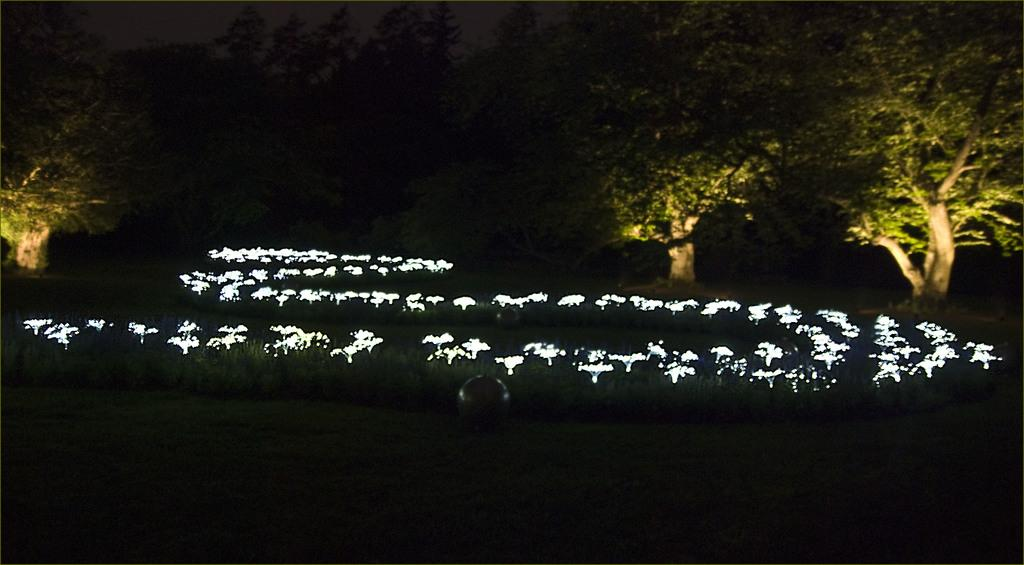What type of natural elements can be seen in the image? There are trees in the image. What type of decoration is present in the image? There are lights as decoration in the image. Can you describe the overall lighting in the image? The image appears to be slightly dark. How does the maid balance the quarter on her nose in the image? There is no maid or quarter present in the image; it only features trees and lights as decoration. 